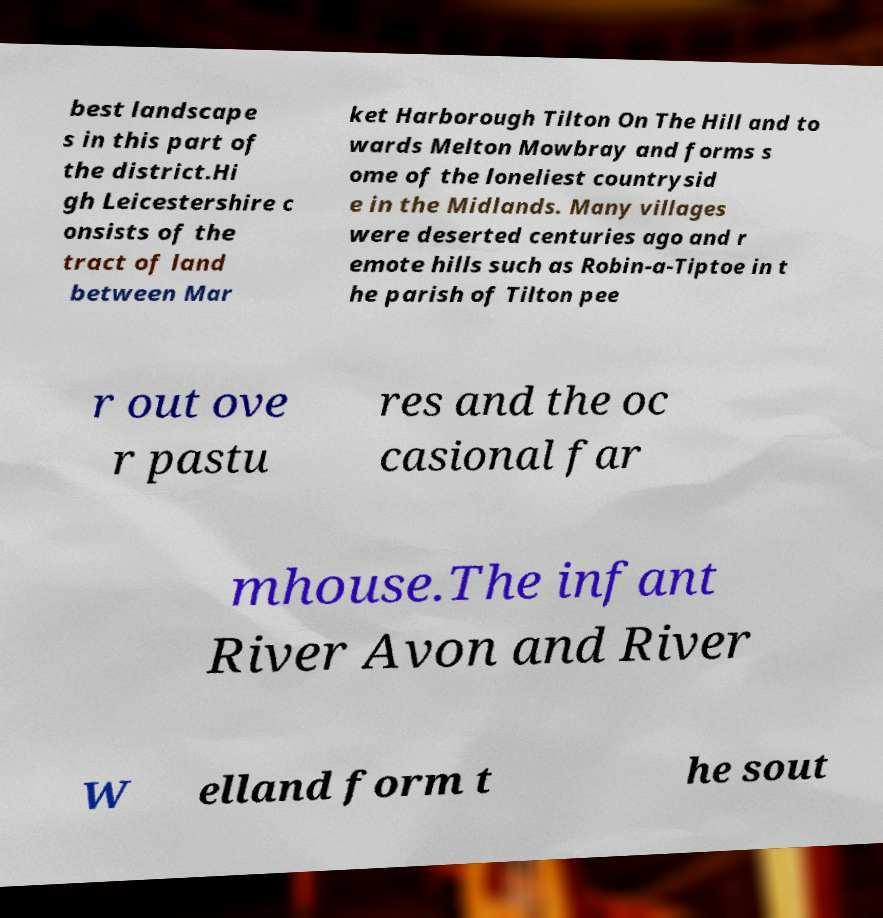Could you extract and type out the text from this image? best landscape s in this part of the district.Hi gh Leicestershire c onsists of the tract of land between Mar ket Harborough Tilton On The Hill and to wards Melton Mowbray and forms s ome of the loneliest countrysid e in the Midlands. Many villages were deserted centuries ago and r emote hills such as Robin-a-Tiptoe in t he parish of Tilton pee r out ove r pastu res and the oc casional far mhouse.The infant River Avon and River W elland form t he sout 